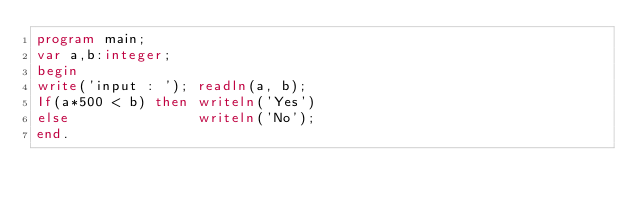<code> <loc_0><loc_0><loc_500><loc_500><_Pascal_>program main;
var a,b:integer;
begin
write('input : '); readln(a, b);
If(a*500 < b) then writeln('Yes') 
else               writeln('No');
end.</code> 